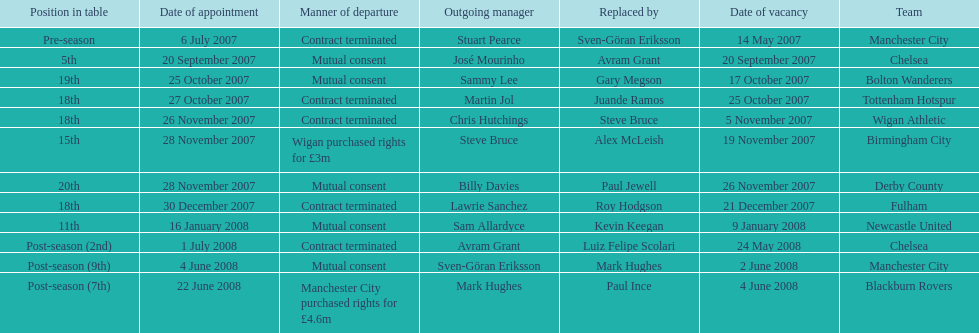Could you parse the entire table? {'header': ['Position in table', 'Date of appointment', 'Manner of departure', 'Outgoing manager', 'Replaced by', 'Date of vacancy', 'Team'], 'rows': [['Pre-season', '6 July 2007', 'Contract terminated', 'Stuart Pearce', 'Sven-Göran Eriksson', '14 May 2007', 'Manchester City'], ['5th', '20 September 2007', 'Mutual consent', 'José Mourinho', 'Avram Grant', '20 September 2007', 'Chelsea'], ['19th', '25 October 2007', 'Mutual consent', 'Sammy Lee', 'Gary Megson', '17 October 2007', 'Bolton Wanderers'], ['18th', '27 October 2007', 'Contract terminated', 'Martin Jol', 'Juande Ramos', '25 October 2007', 'Tottenham Hotspur'], ['18th', '26 November 2007', 'Contract terminated', 'Chris Hutchings', 'Steve Bruce', '5 November 2007', 'Wigan Athletic'], ['15th', '28 November 2007', 'Wigan purchased rights for £3m', 'Steve Bruce', 'Alex McLeish', '19 November 2007', 'Birmingham City'], ['20th', '28 November 2007', 'Mutual consent', 'Billy Davies', 'Paul Jewell', '26 November 2007', 'Derby County'], ['18th', '30 December 2007', 'Contract terminated', 'Lawrie Sanchez', 'Roy Hodgson', '21 December 2007', 'Fulham'], ['11th', '16 January 2008', 'Mutual consent', 'Sam Allardyce', 'Kevin Keegan', '9 January 2008', 'Newcastle United'], ['Post-season (2nd)', '1 July 2008', 'Contract terminated', 'Avram Grant', 'Luiz Felipe Scolari', '24 May 2008', 'Chelsea'], ['Post-season (9th)', '4 June 2008', 'Mutual consent', 'Sven-Göran Eriksson', 'Mark Hughes', '2 June 2008', 'Manchester City'], ['Post-season (7th)', '22 June 2008', 'Manchester City purchased rights for £4.6m', 'Mark Hughes', 'Paul Ince', '4 June 2008', 'Blackburn Rovers']]} Which new manager was purchased for the most money in the 2007-08 premier league season? Mark Hughes. 